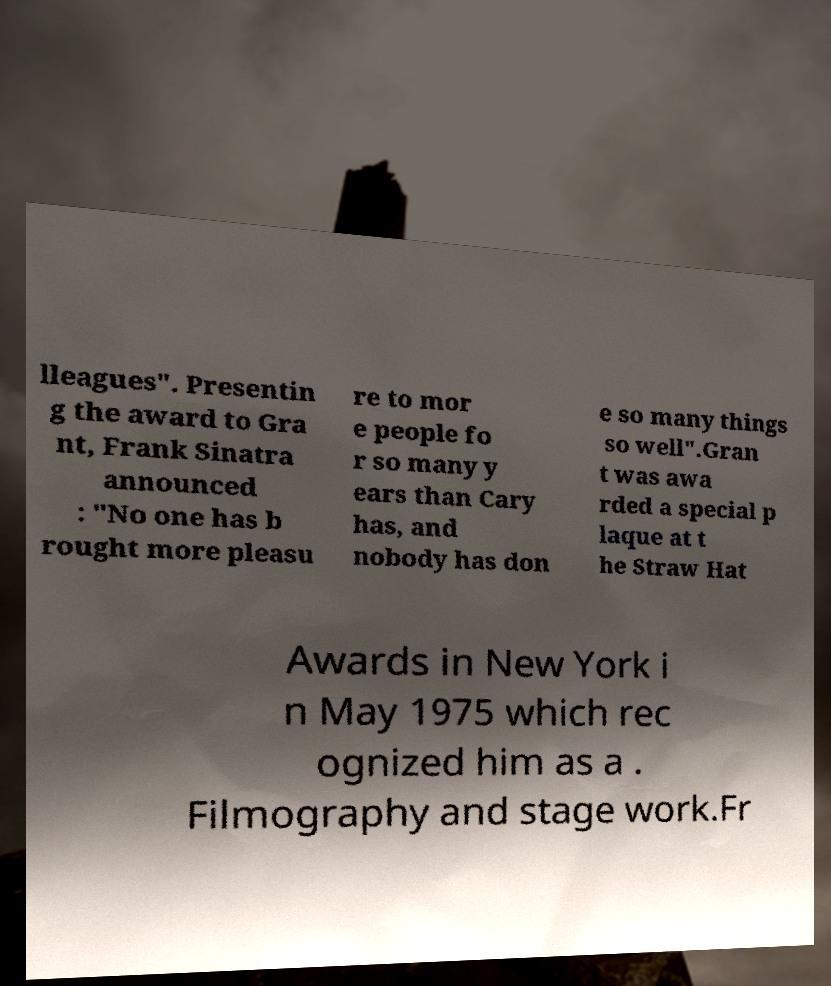Can you read and provide the text displayed in the image?This photo seems to have some interesting text. Can you extract and type it out for me? lleagues". Presentin g the award to Gra nt, Frank Sinatra announced : "No one has b rought more pleasu re to mor e people fo r so many y ears than Cary has, and nobody has don e so many things so well".Gran t was awa rded a special p laque at t he Straw Hat Awards in New York i n May 1975 which rec ognized him as a . Filmography and stage work.Fr 